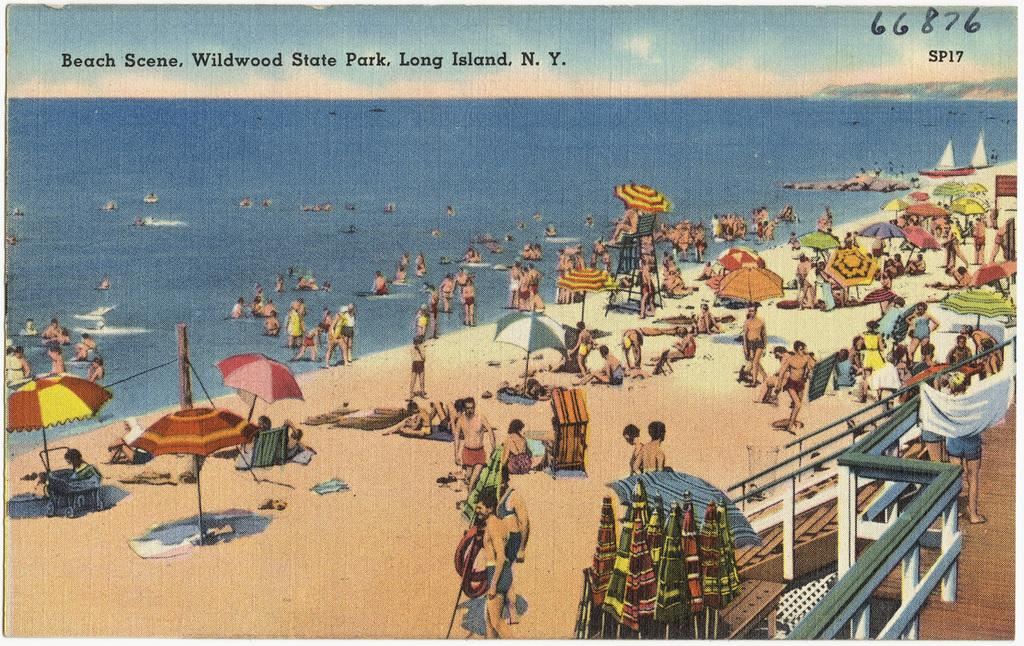<image>
Relay a brief, clear account of the picture shown. A cartoon of people at the beach that is called Beach Scene. 